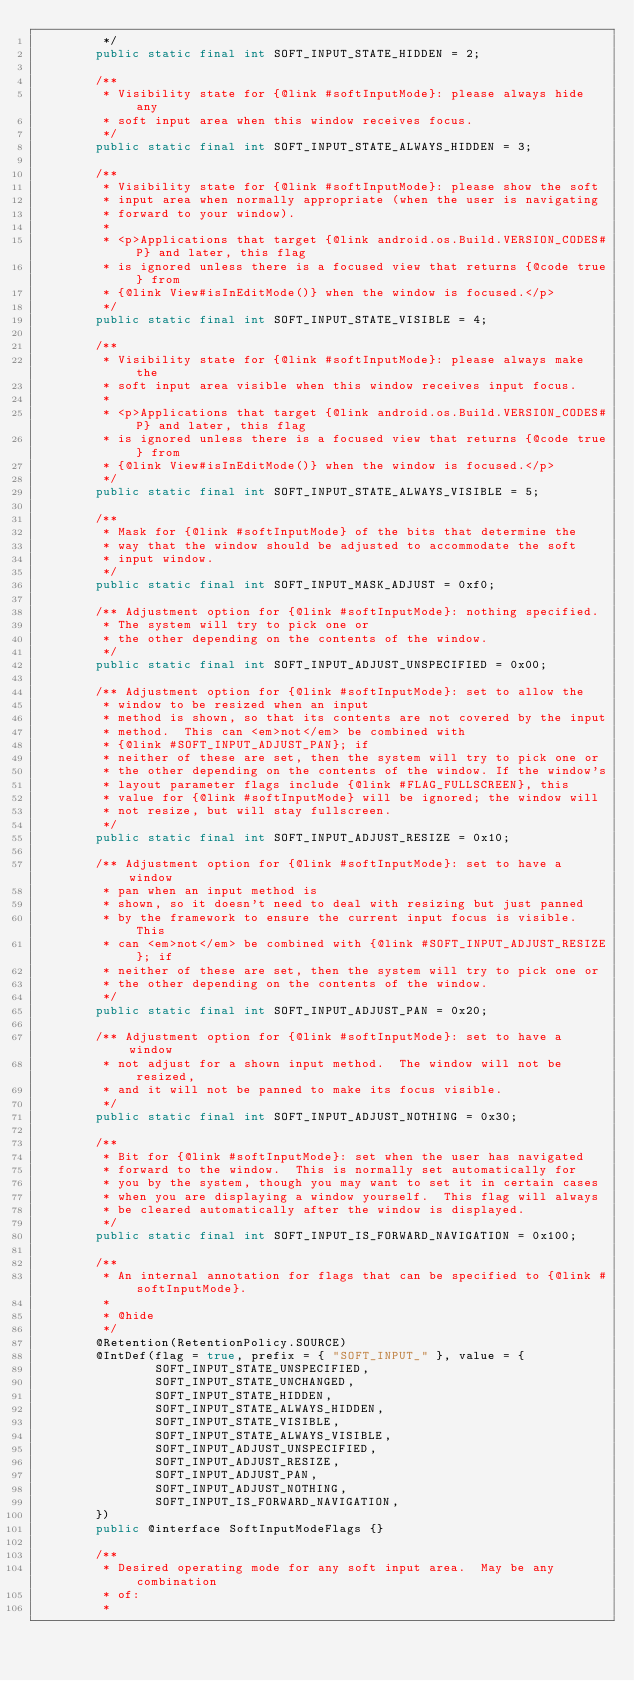<code> <loc_0><loc_0><loc_500><loc_500><_Java_>         */
        public static final int SOFT_INPUT_STATE_HIDDEN = 2;

        /**
         * Visibility state for {@link #softInputMode}: please always hide any
         * soft input area when this window receives focus.
         */
        public static final int SOFT_INPUT_STATE_ALWAYS_HIDDEN = 3;

        /**
         * Visibility state for {@link #softInputMode}: please show the soft
         * input area when normally appropriate (when the user is navigating
         * forward to your window).
         *
         * <p>Applications that target {@link android.os.Build.VERSION_CODES#P} and later, this flag
         * is ignored unless there is a focused view that returns {@code true} from
         * {@link View#isInEditMode()} when the window is focused.</p>
         */
        public static final int SOFT_INPUT_STATE_VISIBLE = 4;

        /**
         * Visibility state for {@link #softInputMode}: please always make the
         * soft input area visible when this window receives input focus.
         *
         * <p>Applications that target {@link android.os.Build.VERSION_CODES#P} and later, this flag
         * is ignored unless there is a focused view that returns {@code true} from
         * {@link View#isInEditMode()} when the window is focused.</p>
         */
        public static final int SOFT_INPUT_STATE_ALWAYS_VISIBLE = 5;

        /**
         * Mask for {@link #softInputMode} of the bits that determine the
         * way that the window should be adjusted to accommodate the soft
         * input window.
         */
        public static final int SOFT_INPUT_MASK_ADJUST = 0xf0;

        /** Adjustment option for {@link #softInputMode}: nothing specified.
         * The system will try to pick one or
         * the other depending on the contents of the window.
         */
        public static final int SOFT_INPUT_ADJUST_UNSPECIFIED = 0x00;

        /** Adjustment option for {@link #softInputMode}: set to allow the
         * window to be resized when an input
         * method is shown, so that its contents are not covered by the input
         * method.  This can <em>not</em> be combined with
         * {@link #SOFT_INPUT_ADJUST_PAN}; if
         * neither of these are set, then the system will try to pick one or
         * the other depending on the contents of the window. If the window's
         * layout parameter flags include {@link #FLAG_FULLSCREEN}, this
         * value for {@link #softInputMode} will be ignored; the window will
         * not resize, but will stay fullscreen.
         */
        public static final int SOFT_INPUT_ADJUST_RESIZE = 0x10;

        /** Adjustment option for {@link #softInputMode}: set to have a window
         * pan when an input method is
         * shown, so it doesn't need to deal with resizing but just panned
         * by the framework to ensure the current input focus is visible.  This
         * can <em>not</em> be combined with {@link #SOFT_INPUT_ADJUST_RESIZE}; if
         * neither of these are set, then the system will try to pick one or
         * the other depending on the contents of the window.
         */
        public static final int SOFT_INPUT_ADJUST_PAN = 0x20;

        /** Adjustment option for {@link #softInputMode}: set to have a window
         * not adjust for a shown input method.  The window will not be resized,
         * and it will not be panned to make its focus visible.
         */
        public static final int SOFT_INPUT_ADJUST_NOTHING = 0x30;

        /**
         * Bit for {@link #softInputMode}: set when the user has navigated
         * forward to the window.  This is normally set automatically for
         * you by the system, though you may want to set it in certain cases
         * when you are displaying a window yourself.  This flag will always
         * be cleared automatically after the window is displayed.
         */
        public static final int SOFT_INPUT_IS_FORWARD_NAVIGATION = 0x100;

        /**
         * An internal annotation for flags that can be specified to {@link #softInputMode}.
         *
         * @hide
         */
        @Retention(RetentionPolicy.SOURCE)
        @IntDef(flag = true, prefix = { "SOFT_INPUT_" }, value = {
                SOFT_INPUT_STATE_UNSPECIFIED,
                SOFT_INPUT_STATE_UNCHANGED,
                SOFT_INPUT_STATE_HIDDEN,
                SOFT_INPUT_STATE_ALWAYS_HIDDEN,
                SOFT_INPUT_STATE_VISIBLE,
                SOFT_INPUT_STATE_ALWAYS_VISIBLE,
                SOFT_INPUT_ADJUST_UNSPECIFIED,
                SOFT_INPUT_ADJUST_RESIZE,
                SOFT_INPUT_ADJUST_PAN,
                SOFT_INPUT_ADJUST_NOTHING,
                SOFT_INPUT_IS_FORWARD_NAVIGATION,
        })
        public @interface SoftInputModeFlags {}

        /**
         * Desired operating mode for any soft input area.  May be any combination
         * of:
         *</code> 